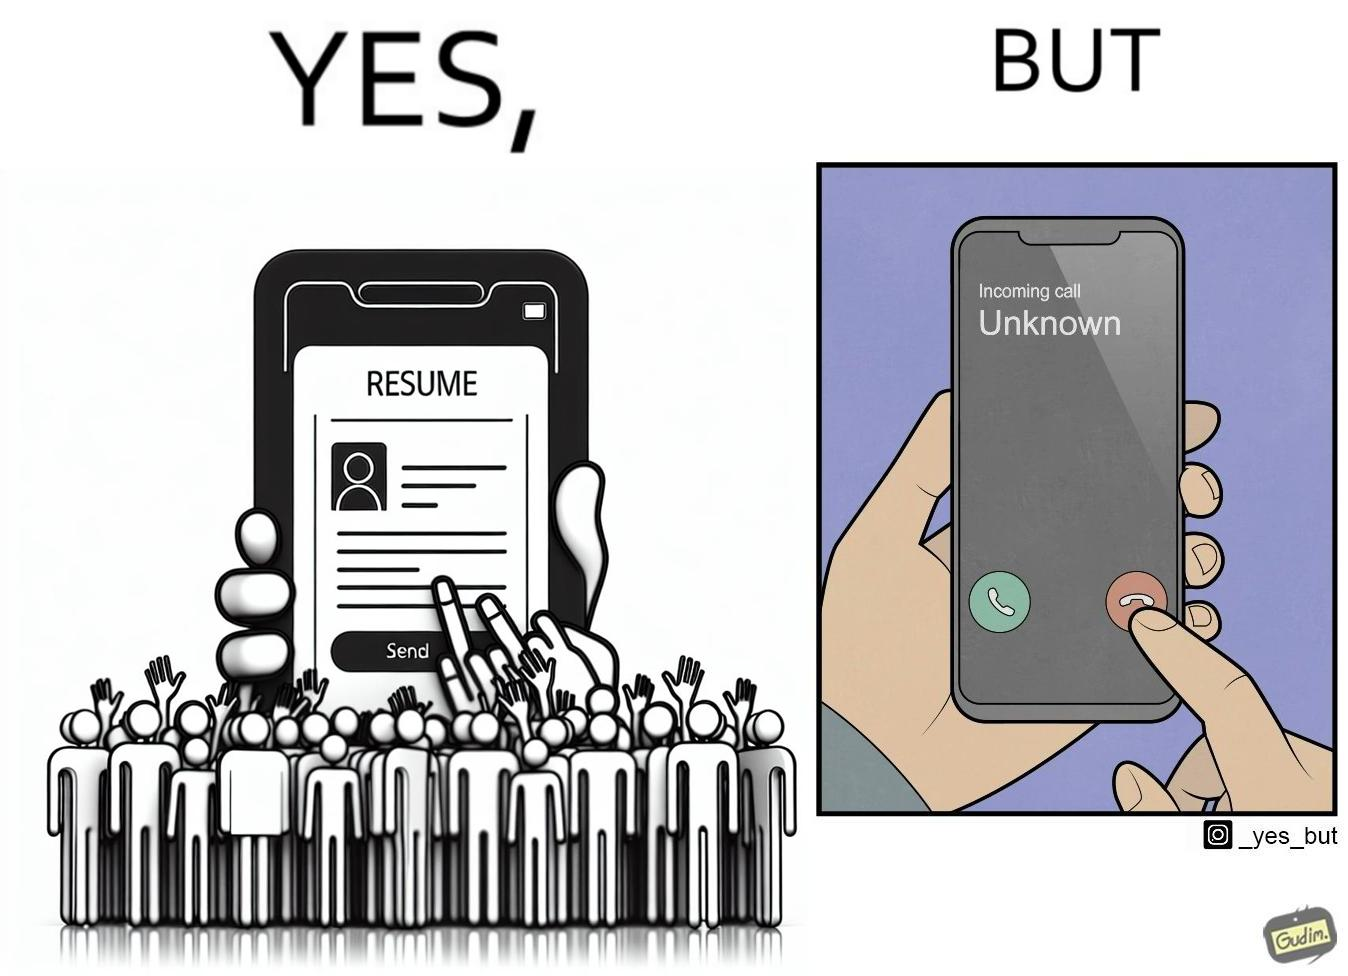Describe the contrast between the left and right parts of this image. In the left part of the image: a mobile screen with resume asking the user whether to send button In the right part of the image: a mobile screen with an incoming call from unknown which the person might be rejecting 